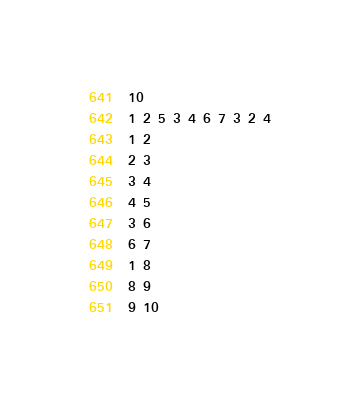Convert code to text. <code><loc_0><loc_0><loc_500><loc_500><_C#_>10
1 2 5 3 4 6 7 3 2 4
1 2
2 3
3 4
4 5
3 6
6 7
1 8
8 9
9 10</code> 